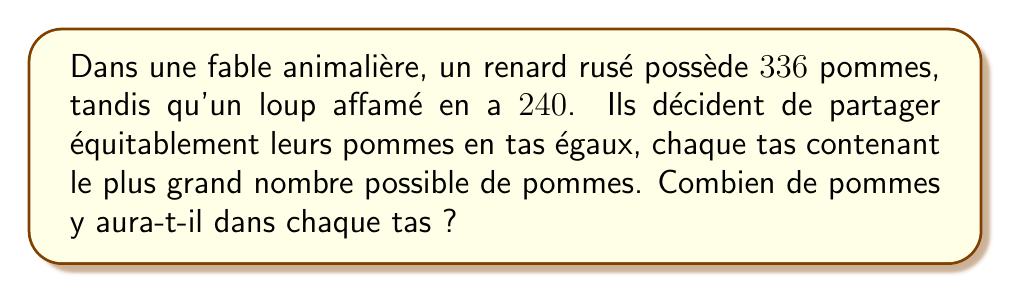Can you solve this math problem? Pour résoudre ce problème, nous devons trouver le plus grand commun diviseur (PGCD) de 336 et 240. Utilisons l'algorithme d'Euclide :

1) Commençons par diviser 336 par 240 :
   $336 = 1 \times 240 + 96$

2) Maintenant, divisons 240 par 96 :
   $240 = 2 \times 96 + 48$

3) Divisons 96 par 48 :
   $96 = 2 \times 48 + 0$

4) Le processus s'arrête ici car le reste est 0. Le dernier diviseur non nul (48) est le PGCD.

Donc, le PGCD de 336 et 240 est 48.

Vérifions :
$336 = 48 \times 7$
$240 = 48 \times 5$

Ainsi, le plus grand nombre de pommes possible dans chaque tas est 48.
Answer: 48 